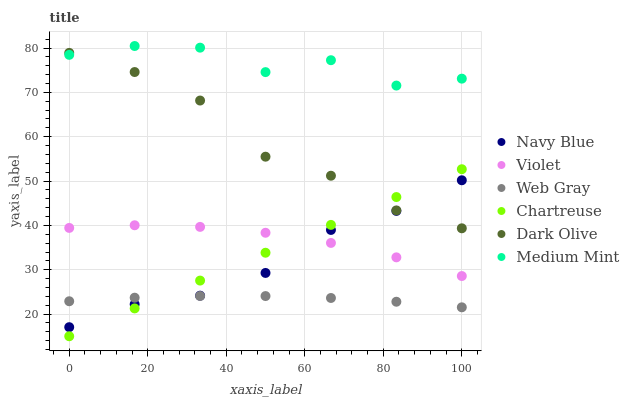Does Web Gray have the minimum area under the curve?
Answer yes or no. Yes. Does Medium Mint have the maximum area under the curve?
Answer yes or no. Yes. Does Navy Blue have the minimum area under the curve?
Answer yes or no. No. Does Navy Blue have the maximum area under the curve?
Answer yes or no. No. Is Chartreuse the smoothest?
Answer yes or no. Yes. Is Medium Mint the roughest?
Answer yes or no. Yes. Is Web Gray the smoothest?
Answer yes or no. No. Is Web Gray the roughest?
Answer yes or no. No. Does Chartreuse have the lowest value?
Answer yes or no. Yes. Does Web Gray have the lowest value?
Answer yes or no. No. Does Medium Mint have the highest value?
Answer yes or no. Yes. Does Navy Blue have the highest value?
Answer yes or no. No. Is Web Gray less than Dark Olive?
Answer yes or no. Yes. Is Medium Mint greater than Web Gray?
Answer yes or no. Yes. Does Chartreuse intersect Violet?
Answer yes or no. Yes. Is Chartreuse less than Violet?
Answer yes or no. No. Is Chartreuse greater than Violet?
Answer yes or no. No. Does Web Gray intersect Dark Olive?
Answer yes or no. No. 